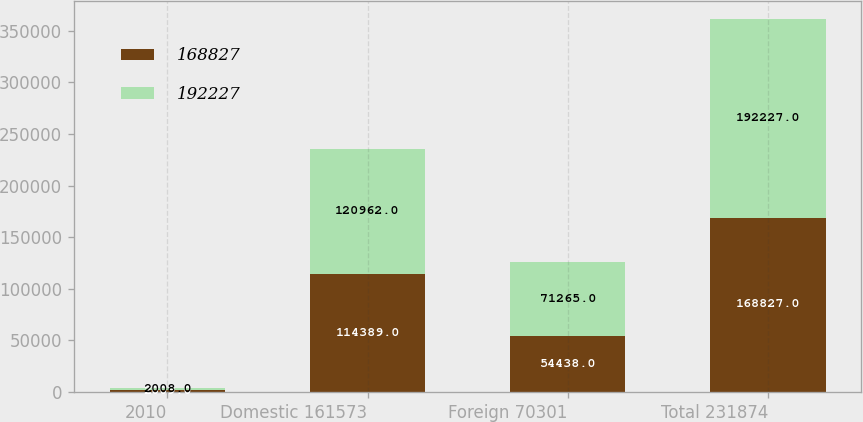Convert chart to OTSL. <chart><loc_0><loc_0><loc_500><loc_500><stacked_bar_chart><ecel><fcel>2010<fcel>Domestic 161573<fcel>Foreign 70301<fcel>Total 231874<nl><fcel>168827<fcel>2009<fcel>114389<fcel>54438<fcel>168827<nl><fcel>192227<fcel>2008<fcel>120962<fcel>71265<fcel>192227<nl></chart> 